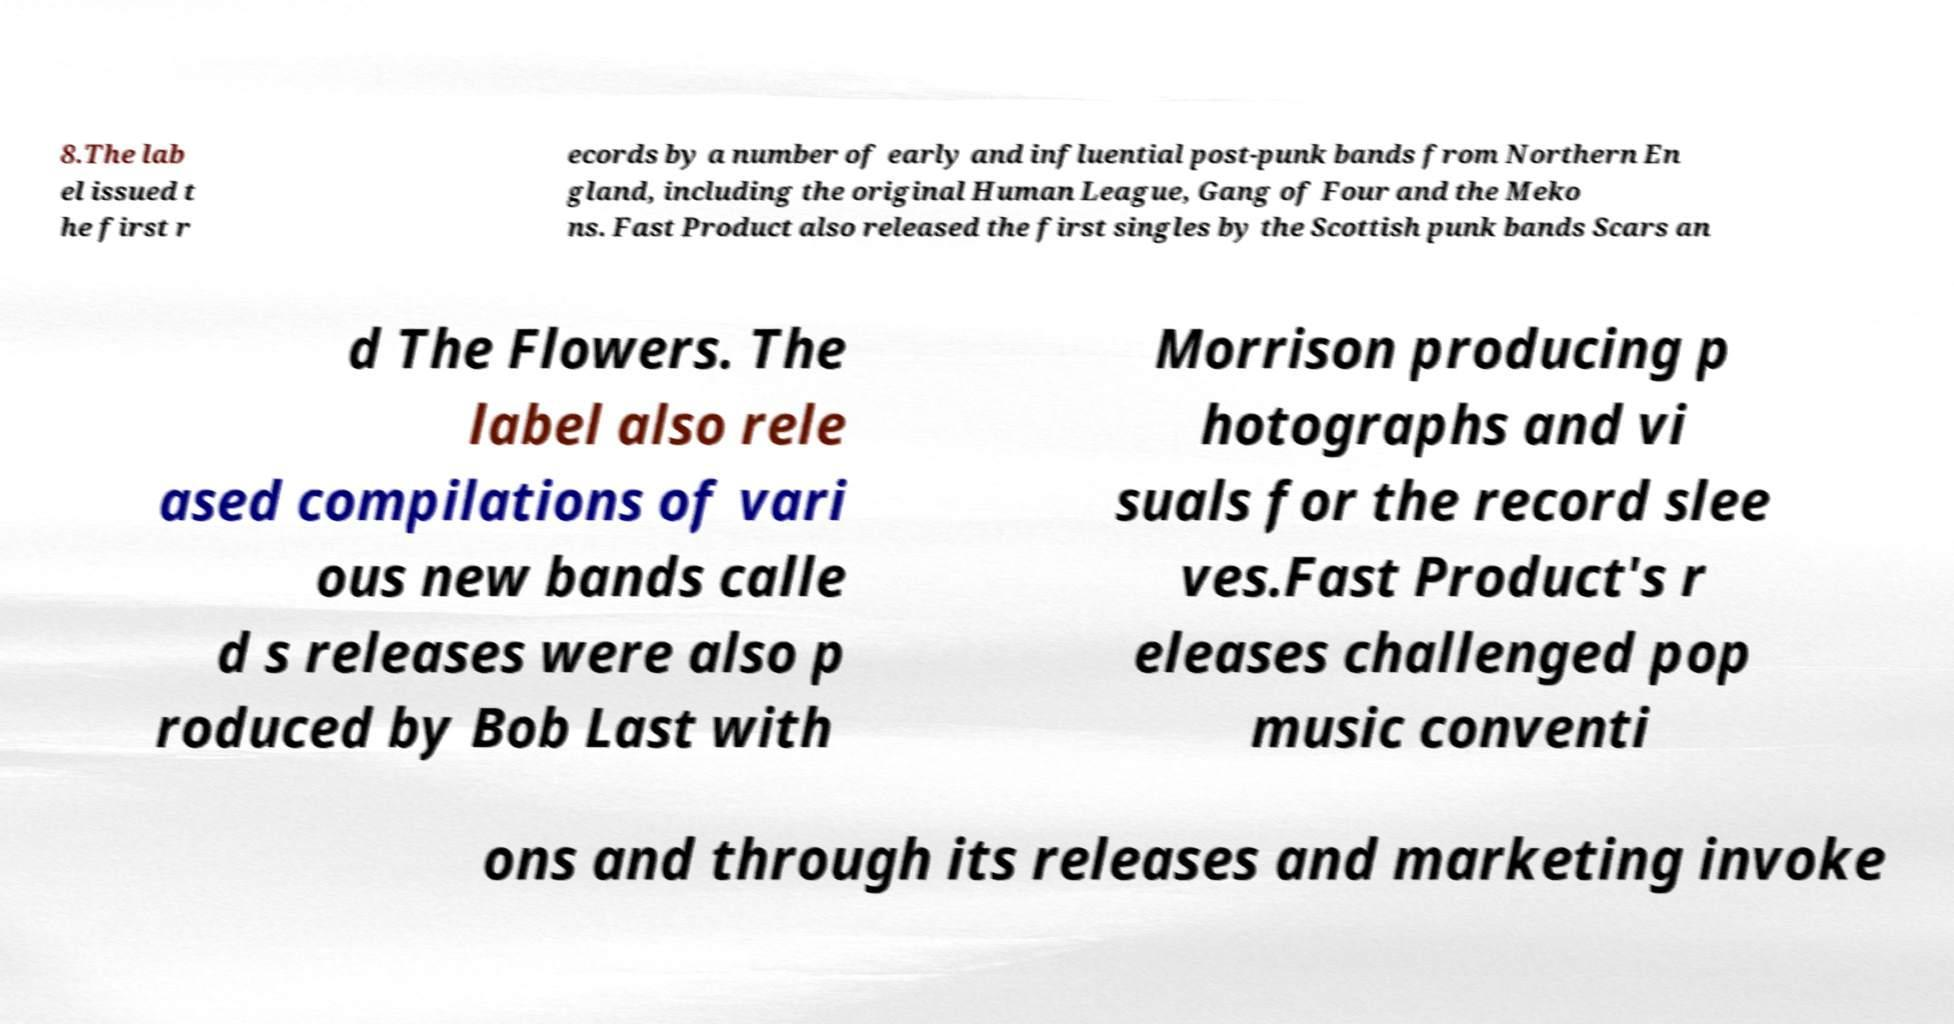I need the written content from this picture converted into text. Can you do that? 8.The lab el issued t he first r ecords by a number of early and influential post-punk bands from Northern En gland, including the original Human League, Gang of Four and the Meko ns. Fast Product also released the first singles by the Scottish punk bands Scars an d The Flowers. The label also rele ased compilations of vari ous new bands calle d s releases were also p roduced by Bob Last with Morrison producing p hotographs and vi suals for the record slee ves.Fast Product's r eleases challenged pop music conventi ons and through its releases and marketing invoke 